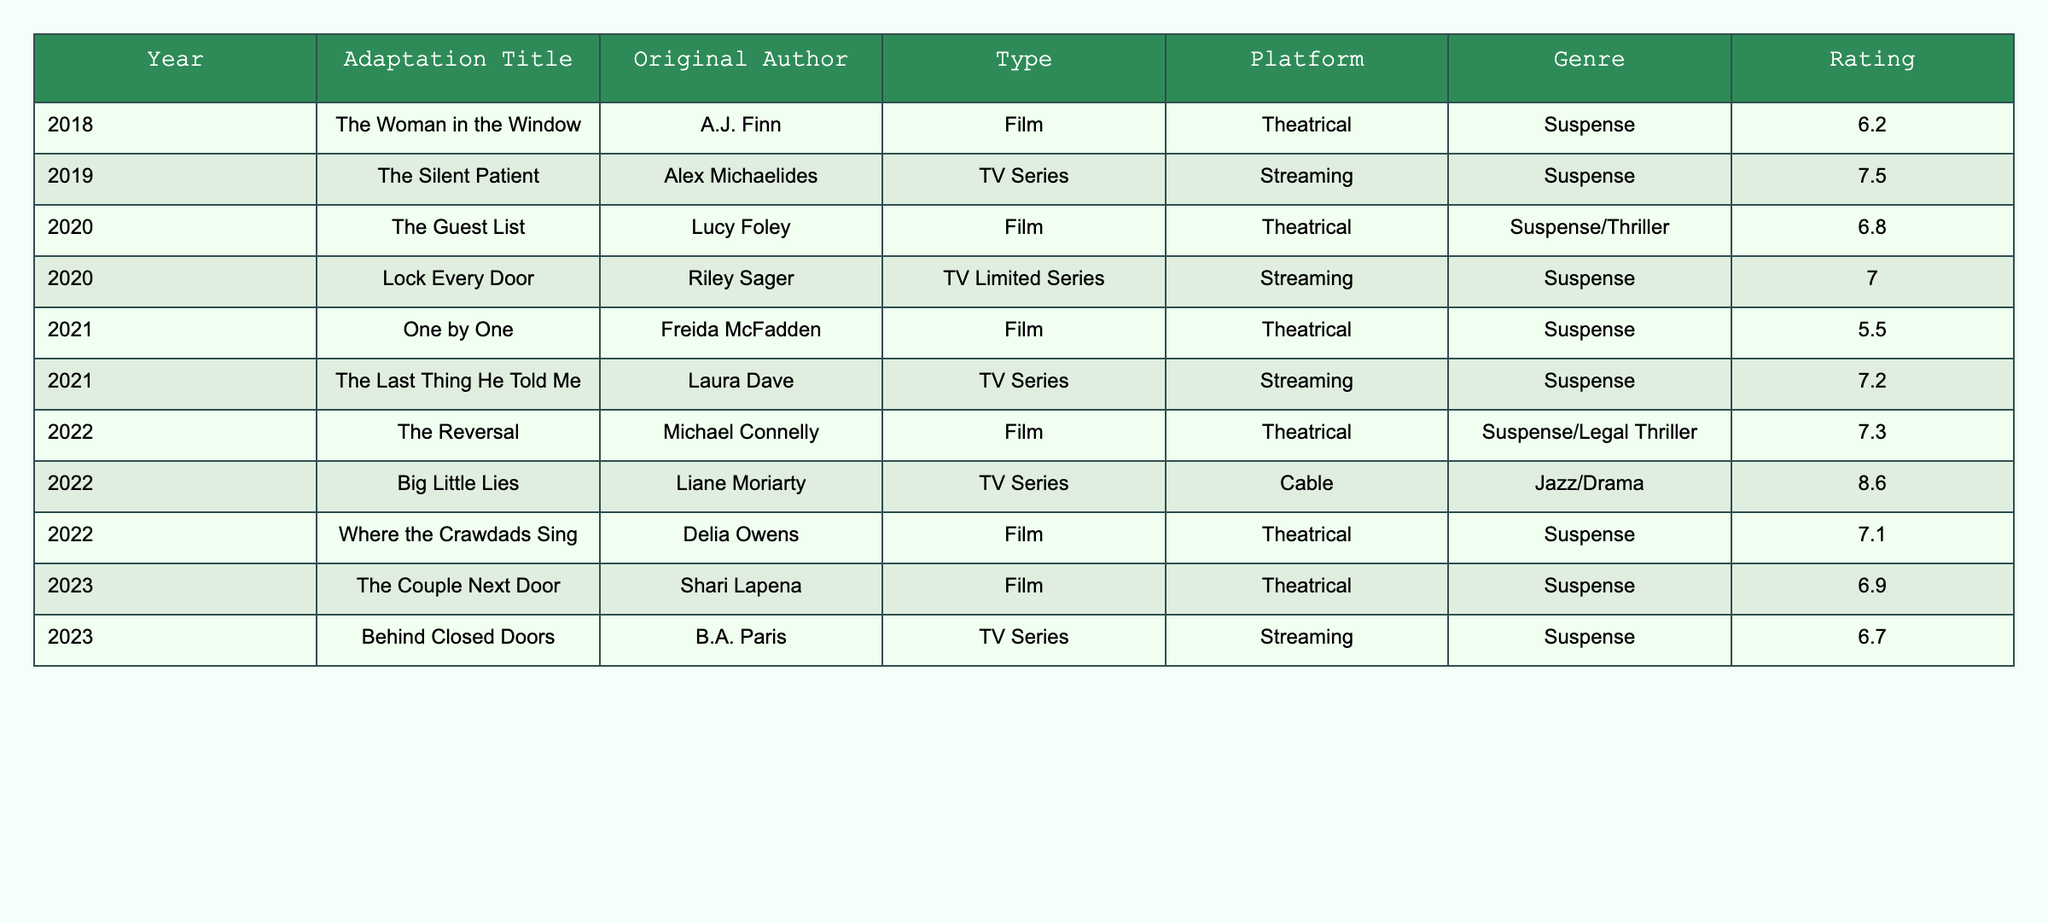What year had the adaptation titled "The Silent Patient"? By looking at the table, we can find the title "The Silent Patient" in the row corresponding to the year. It is clearly listed under the "Year" column.
Answer: 2019 What is the average rating of adaptations released in 2020? In 2020, there are two adaptations: "The Guest List" with a rating of 6.8 and "Lock Every Door" with a rating of 7.0. To find the average, we sum the ratings (6.8 + 7.0 = 13.8) and then divide by the number of adaptations (2). Thus, the average rating is 13.8 / 2 = 6.9.
Answer: 6.9 Did any adaptations receive a rating above 8? By examining the ratings in the table, we can see that "Big Little Lies" has a rating of 8.6, which is above 8.
Answer: Yes How many adaptations were released in 2022? We can count the number of rows in the table for the year 2022. The adaptations listed for that year are "The Reversal," "Big Little Lies," and "Where the Crawdads Sing," totaling three adaptations.
Answer: 3 Which author had an adaptation released in 2021 that received a rating below 6? Looking through the adaptations for 2021, we find that "One by One" by Freida McFadden has a rating of 5.5, which is below 6.
Answer: Freida McFadden What is the difference in ratings between the highest-rated adaptation and the lowest-rated adaptation among those listed? After identifying the highest rating (8.6 for "Big Little Lies") and the lowest rating (5.5 for "One by One"), we calculate the difference: 8.6 - 5.5 = 3.1.
Answer: 3.1 How many adaptations were adapted from novels classified strictly as suspense? By reviewing the "Genre" column under the adaptations, we see that the adaptations fitting strictly within the suspense genre are "The Woman in the Window," "The Silent Patient," "Lock Every Door," "One by One," "Where the Crawdads Sing," and "The Couple Next Door." Thus, there are six adaptations.
Answer: 6 In which year did the TV series adaptation "Behind Closed Doors" release? The title "Behind Closed Doors" appears in the row for the year 2023 in the table.
Answer: 2023 